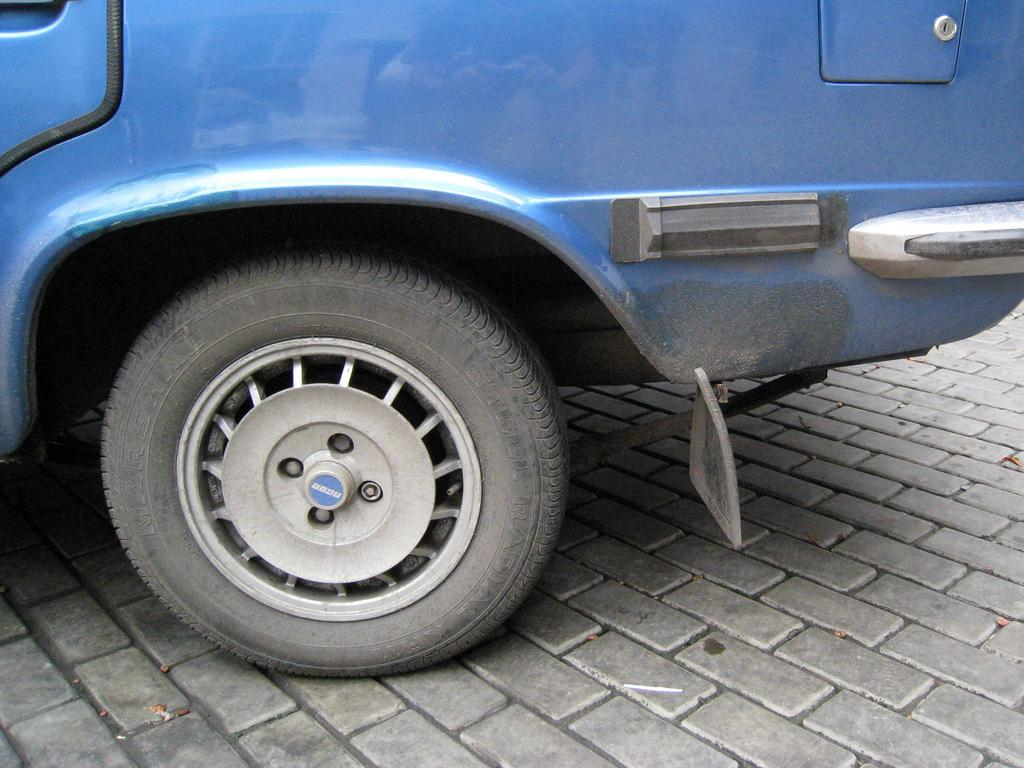What is the main subject of the image? The main subject of the image is a vehicle. Where is the vehicle located in the image? The vehicle is on the ground in the image. Can you describe any other elements in the image? There is a tier in the image. How many flowers are being held by the brother in the image? There is no brother or flowers present in the image. 